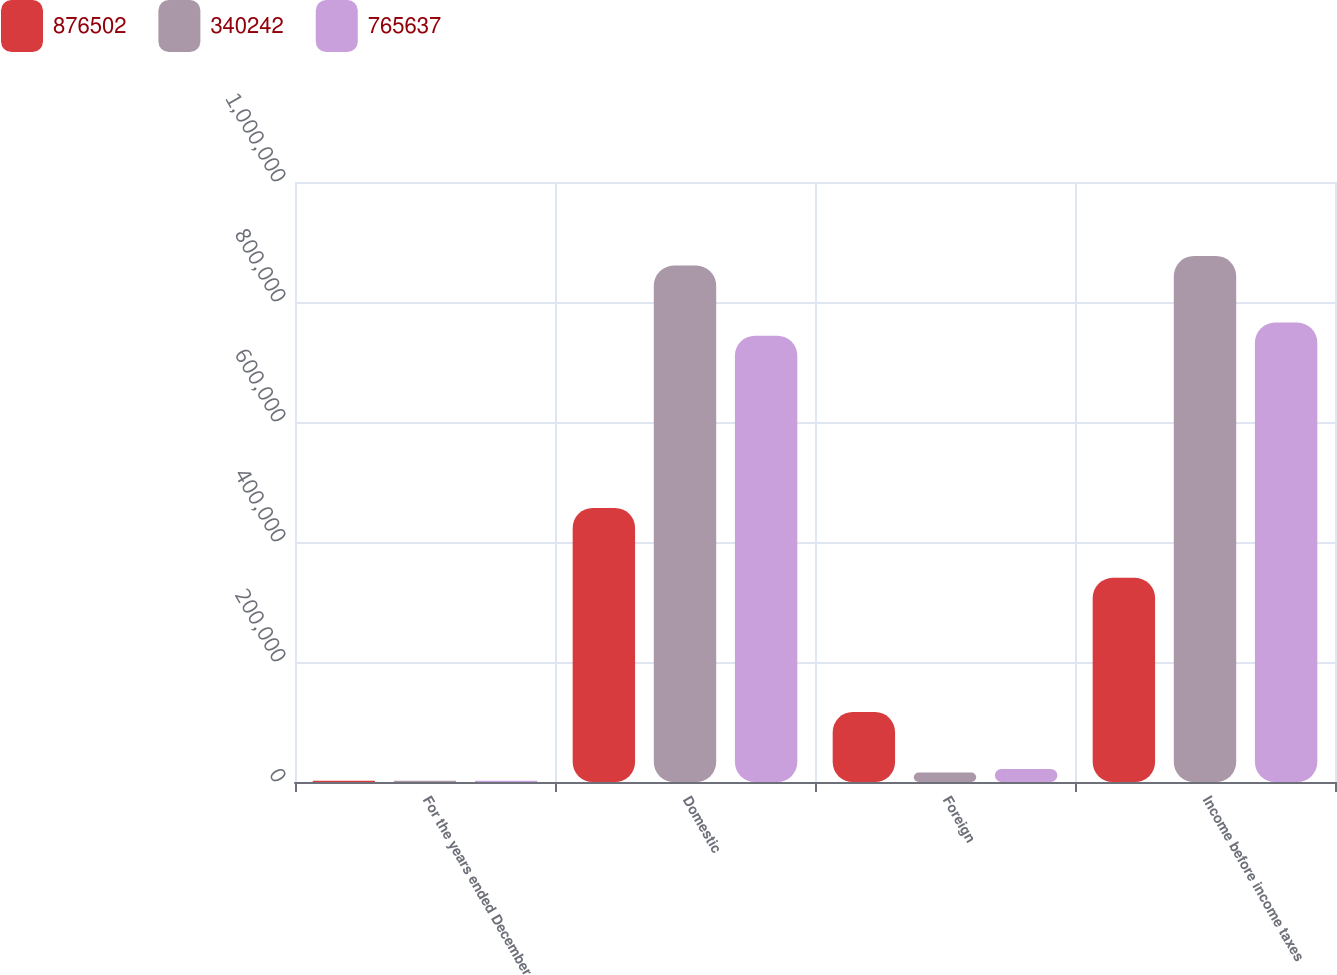<chart> <loc_0><loc_0><loc_500><loc_500><stacked_bar_chart><ecel><fcel>For the years ended December<fcel>Domestic<fcel>Foreign<fcel>Income before income taxes<nl><fcel>876502<fcel>2007<fcel>456856<fcel>116614<fcel>340242<nl><fcel>340242<fcel>2006<fcel>860655<fcel>15847<fcel>876502<nl><fcel>765637<fcel>2005<fcel>743834<fcel>21803<fcel>765637<nl></chart> 